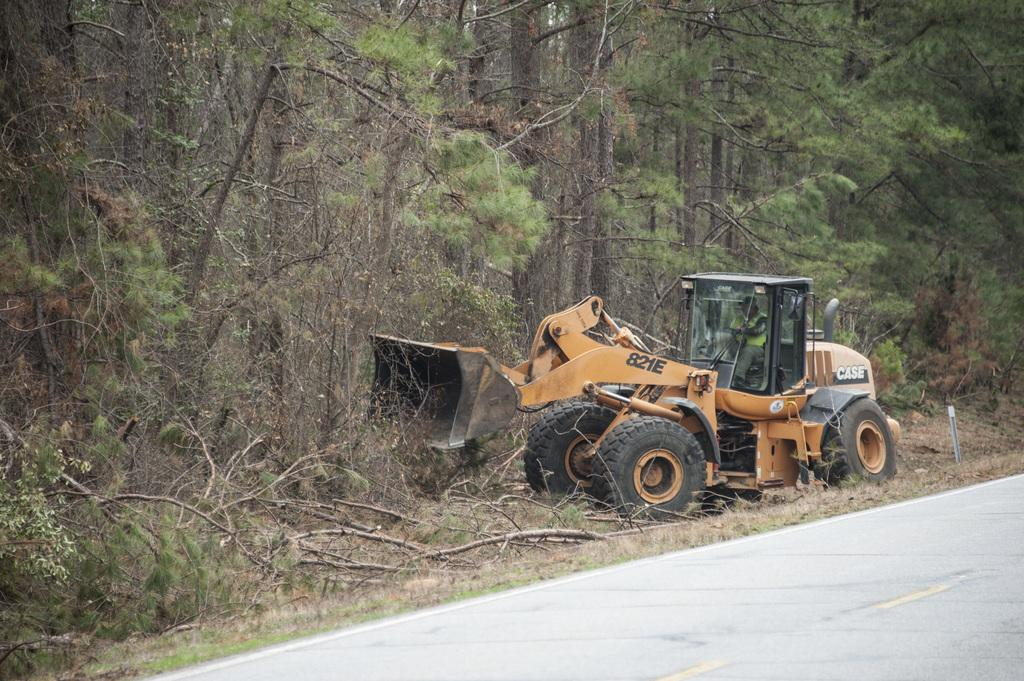<image>
Write a terse but informative summary of the picture. 821E sign on a a case heavy equipment machine. 